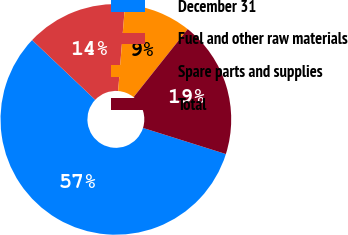<chart> <loc_0><loc_0><loc_500><loc_500><pie_chart><fcel>December 31<fcel>Fuel and other raw materials<fcel>Spare parts and supplies<fcel>Total<nl><fcel>57.21%<fcel>14.2%<fcel>9.43%<fcel>19.16%<nl></chart> 